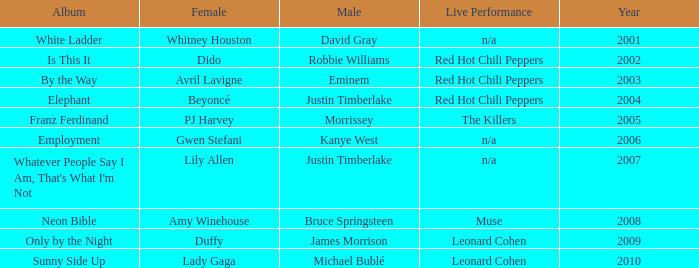Who is the male partner for amy winehouse? Bruce Springsteen. 